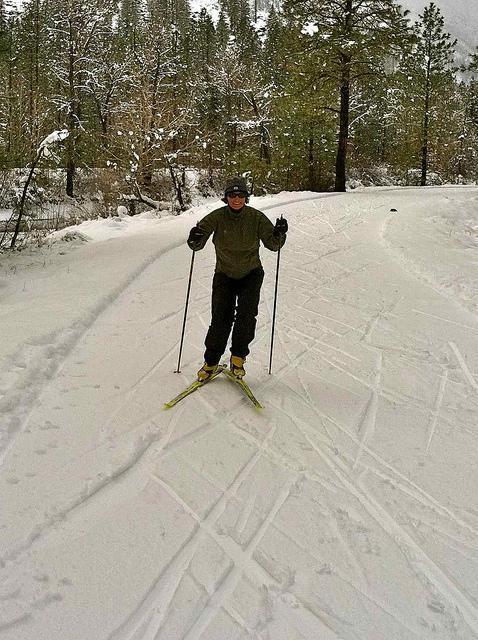How many horses in the photo?
Give a very brief answer. 0. 